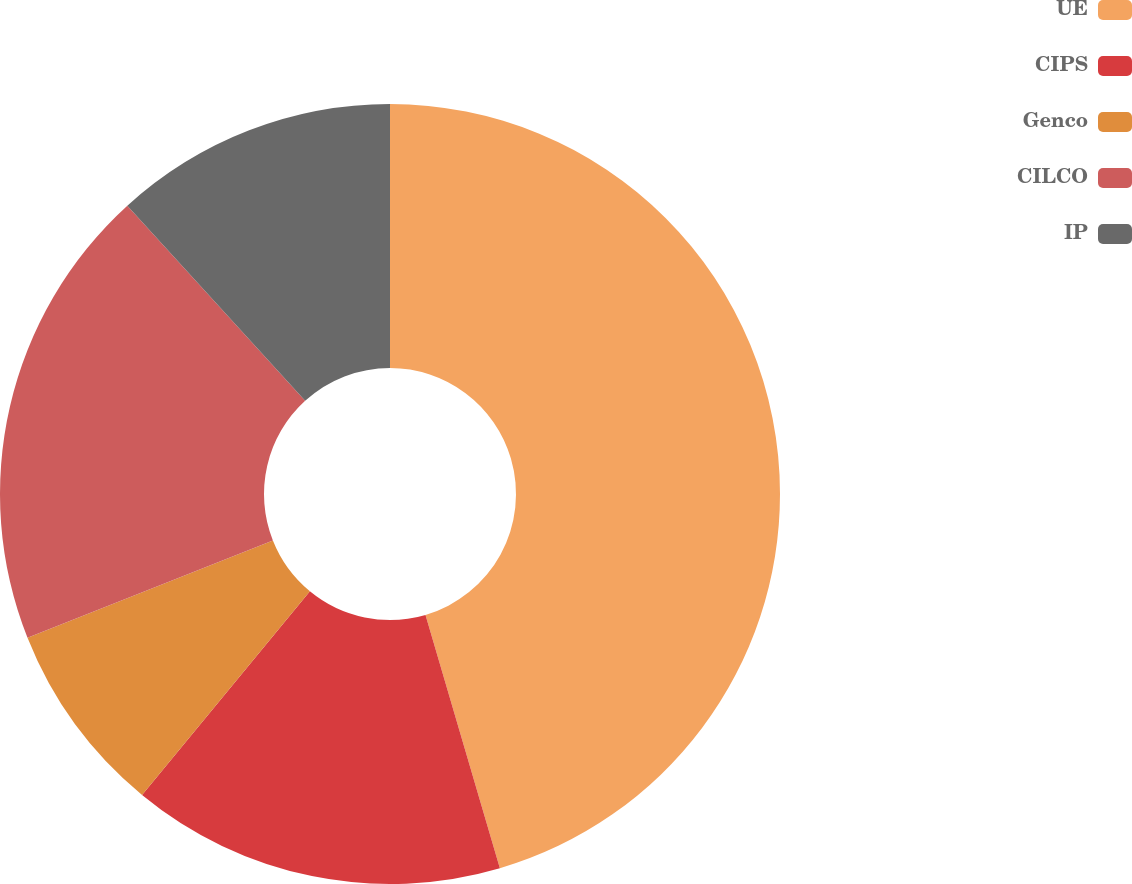Convert chart to OTSL. <chart><loc_0><loc_0><loc_500><loc_500><pie_chart><fcel>UE<fcel>CIPS<fcel>Genco<fcel>CILCO<fcel>IP<nl><fcel>45.45%<fcel>15.51%<fcel>8.02%<fcel>19.25%<fcel>11.76%<nl></chart> 